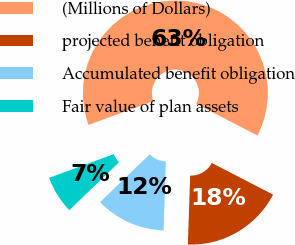Convert chart to OTSL. <chart><loc_0><loc_0><loc_500><loc_500><pie_chart><fcel>(Millions of Dollars)<fcel>projected benefit obligation<fcel>Accumulated benefit obligation<fcel>Fair value of plan assets<nl><fcel>63.2%<fcel>17.93%<fcel>12.27%<fcel>6.61%<nl></chart> 